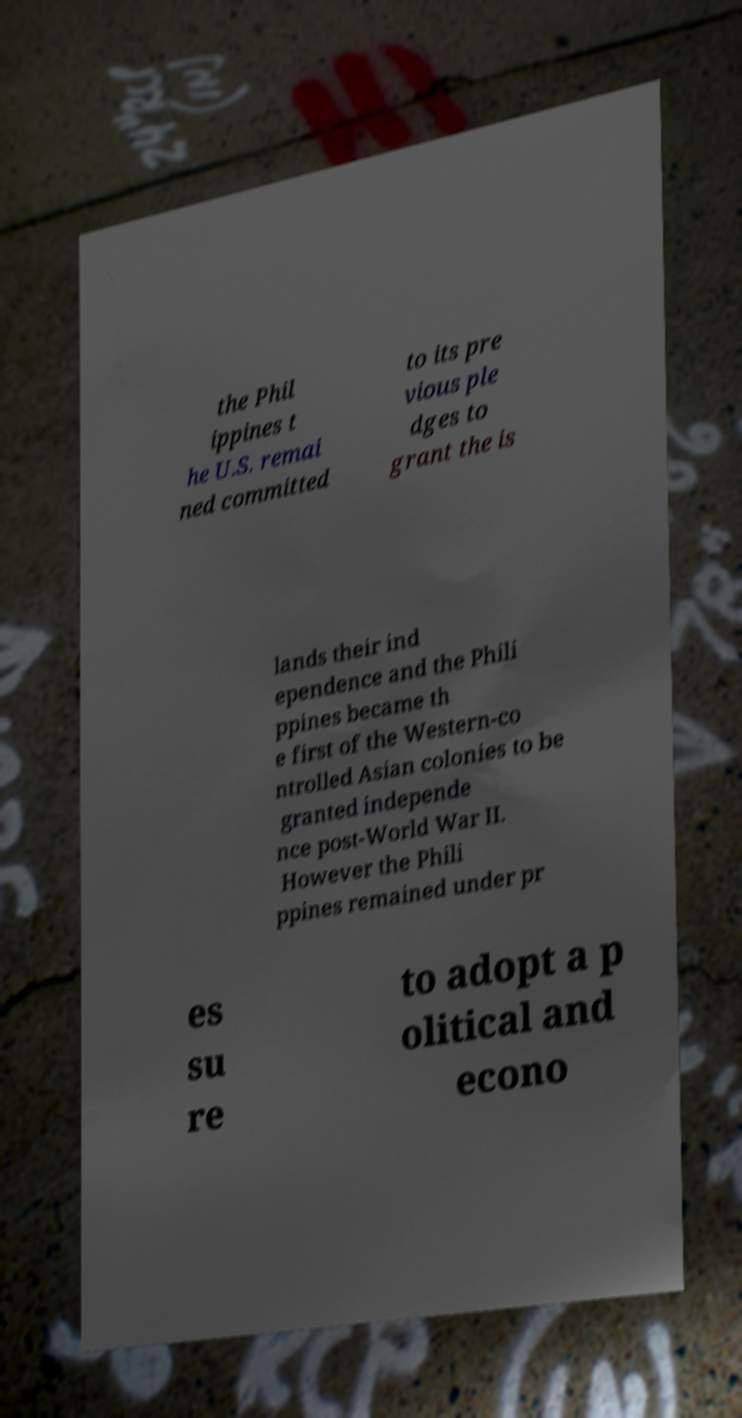There's text embedded in this image that I need extracted. Can you transcribe it verbatim? the Phil ippines t he U.S. remai ned committed to its pre vious ple dges to grant the is lands their ind ependence and the Phili ppines became th e first of the Western-co ntrolled Asian colonies to be granted independe nce post-World War II. However the Phili ppines remained under pr es su re to adopt a p olitical and econo 